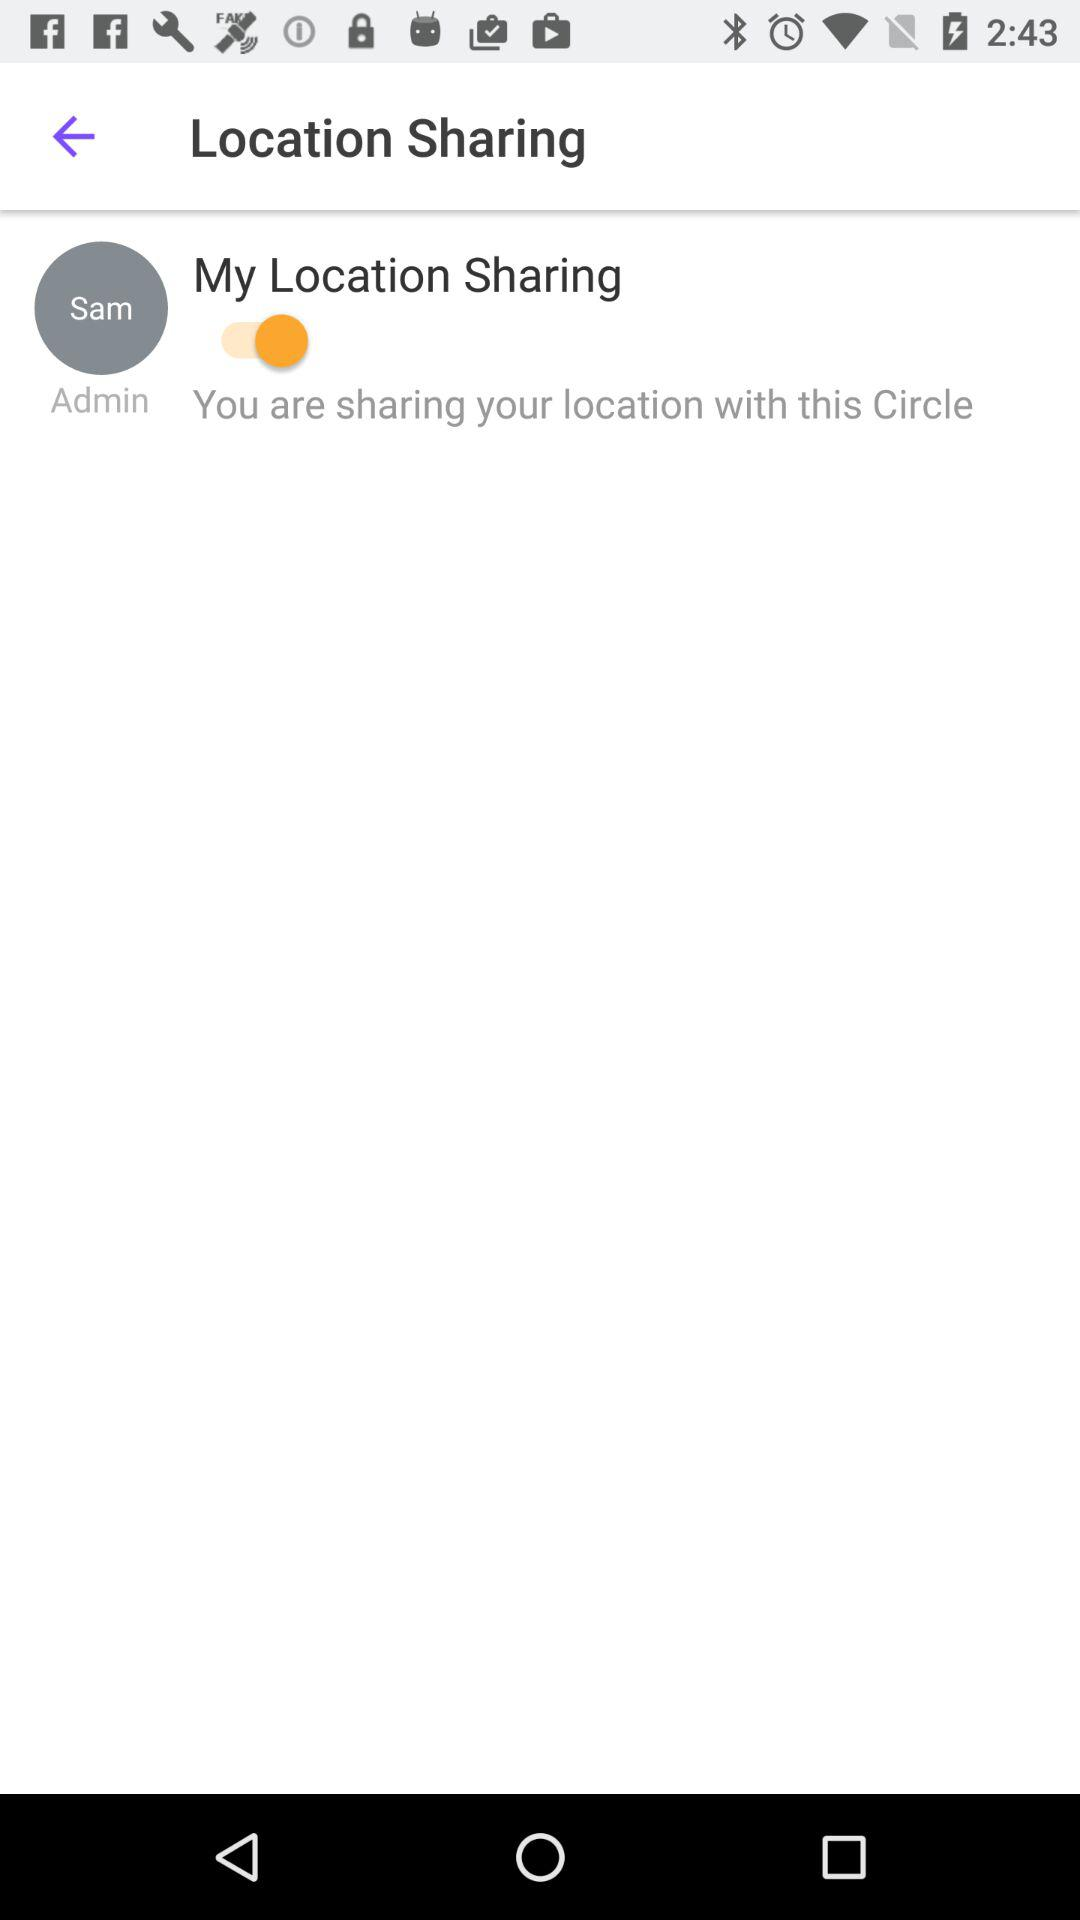What is the status of "My Location Sharing"? The status of "My Location Sharing" is "on". 